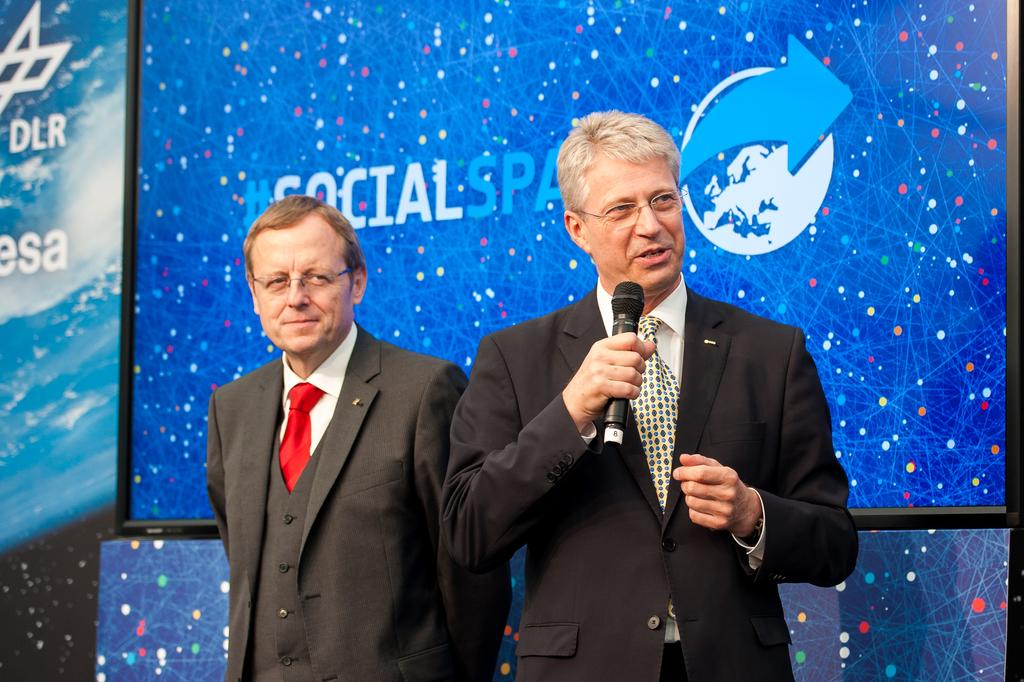How many people are in the image? There are two men in the image. What are the men wearing? Both men are wearing suits. What is one of the men holding? One of the men is holding a microphone. What type of plantation can be seen in the background of the image? There is no plantation visible in the image; it only features two men wearing suits, one of whom is holding a microphone. 